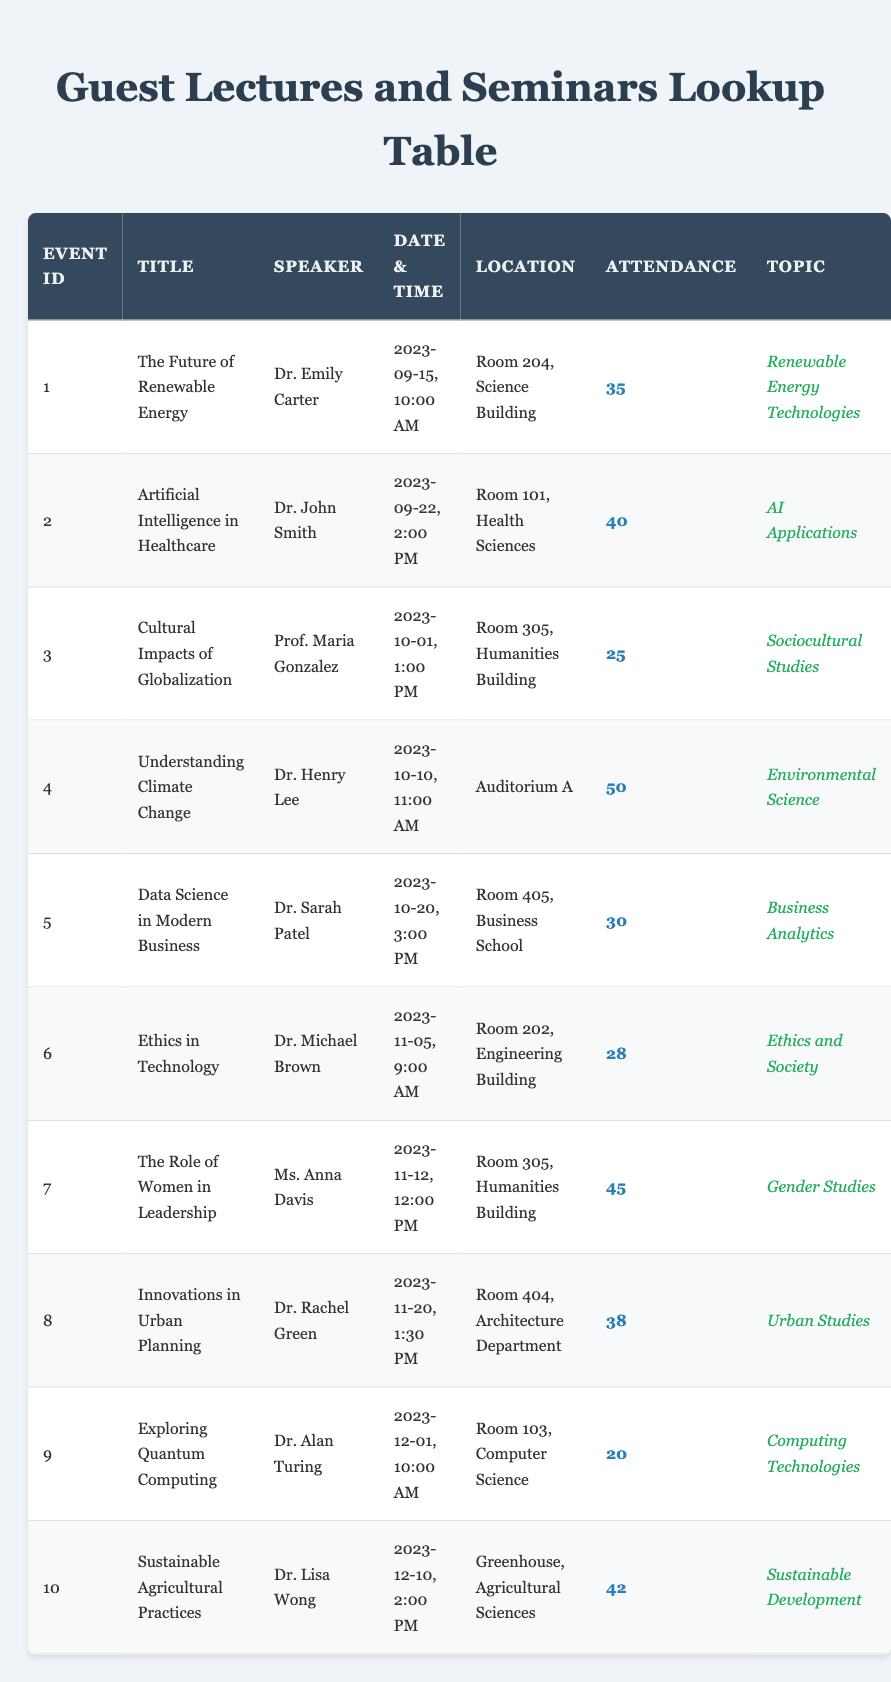What is the attendance for the event titled "Understanding Climate Change"? By locating the row with the title "Understanding Climate Change," we find that the attendance column shows the number of attendees is 50.
Answer: 50 Who is the speaker for the seminar on "Cultural Impacts of Globalization"? The row for "Cultural Impacts of Globalization" lists Prof. Maria Gonzalez as the speaker.
Answer: Prof. Maria Gonzalez What is the date and time for the guest lecture on "Artificial Intelligence in Healthcare"? In the row for "Artificial Intelligence in Healthcare," the date and time are listed as September 22, 2023, at 2:00 PM.
Answer: September 22, 2023, 2:00 PM What is the average attendance for all events? To find the average attendance, we sum the attendance values: 35 + 40 + 25 + 50 + 30 + 28 + 45 + 38 + 20 + 42 =  353. There are 10 events, so the average is 353 divided by 10, which equals 35.3.
Answer: 35.3 Did the event on "Exploring Quantum Computing" have an attendance of more than 25? Upon checking the attendance for "Exploring Quantum Computing," the attendance is noted as 20, which is less than 25. Hence, the answer is no.
Answer: No What was the location of the seminar presented by Dr. Sarah Patel? Looking at the row for "Data Science in Modern Business," the location is Room 405, Business School.
Answer: Room 405, Business School Identify the event that had the highest attendance and state that attendance number. By examining each event's attendance, the event with the highest number is "Understanding Climate Change" with an attendance of 50, as it is the greatest value in the attendance column.
Answer: 50 How many events were held in the Humanities Building? The events that took place in the Humanities Building are "Cultural Impacts of Globalization" and "The Role of Women in Leadership," making a total count of 2 events.
Answer: 2 What is the topic of the event led by Dr. Michael Brown? Referring to the row for "Ethics in Technology," the topic listed is "Ethics and Society."
Answer: Ethics and Society 